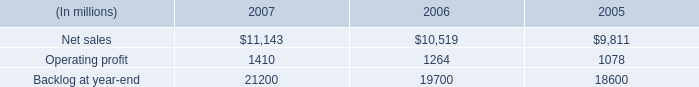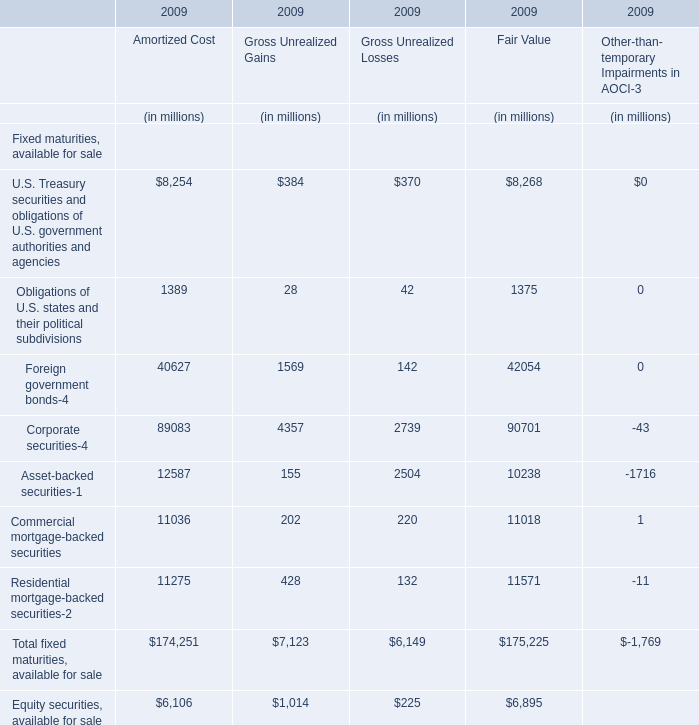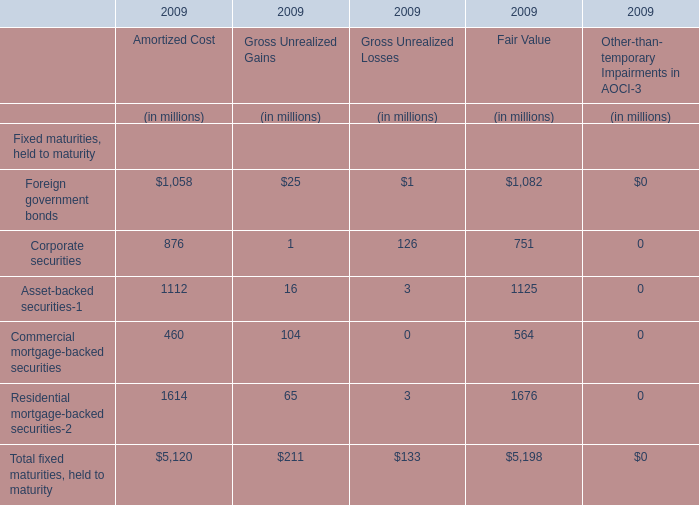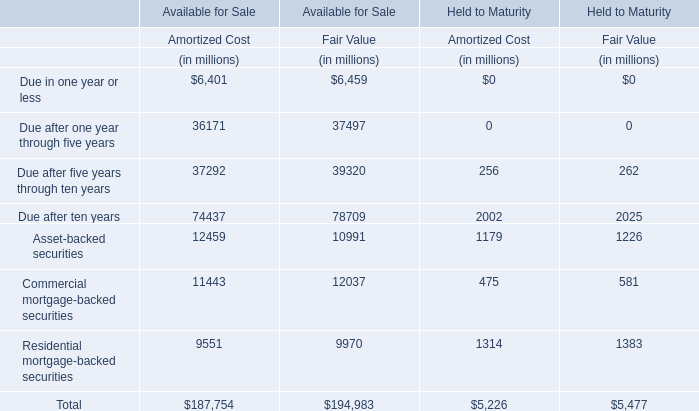What's the total value of all Amortized Cost that are smaller than 20000 for Available for Sale? (in million) 
Computations: (((12459 + 11443) + 9551) + 6401)
Answer: 39854.0. 